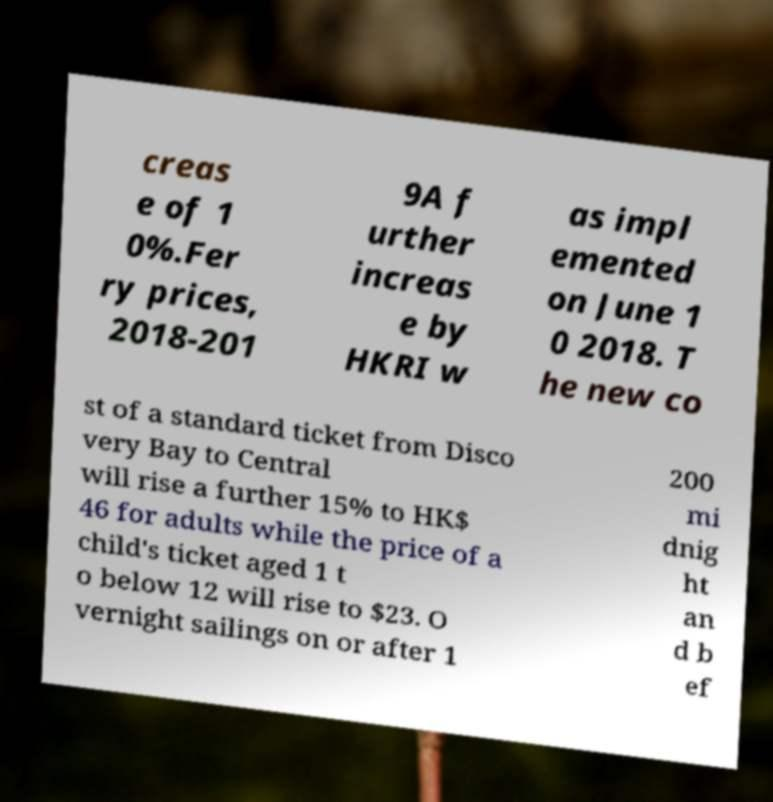There's text embedded in this image that I need extracted. Can you transcribe it verbatim? creas e of 1 0%.Fer ry prices, 2018-201 9A f urther increas e by HKRI w as impl emented on June 1 0 2018. T he new co st of a standard ticket from Disco very Bay to Central will rise a further 15% to HK$ 46 for adults while the price of a child's ticket aged 1 t o below 12 will rise to $23. O vernight sailings on or after 1 200 mi dnig ht an d b ef 